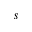<formula> <loc_0><loc_0><loc_500><loc_500>s</formula> 